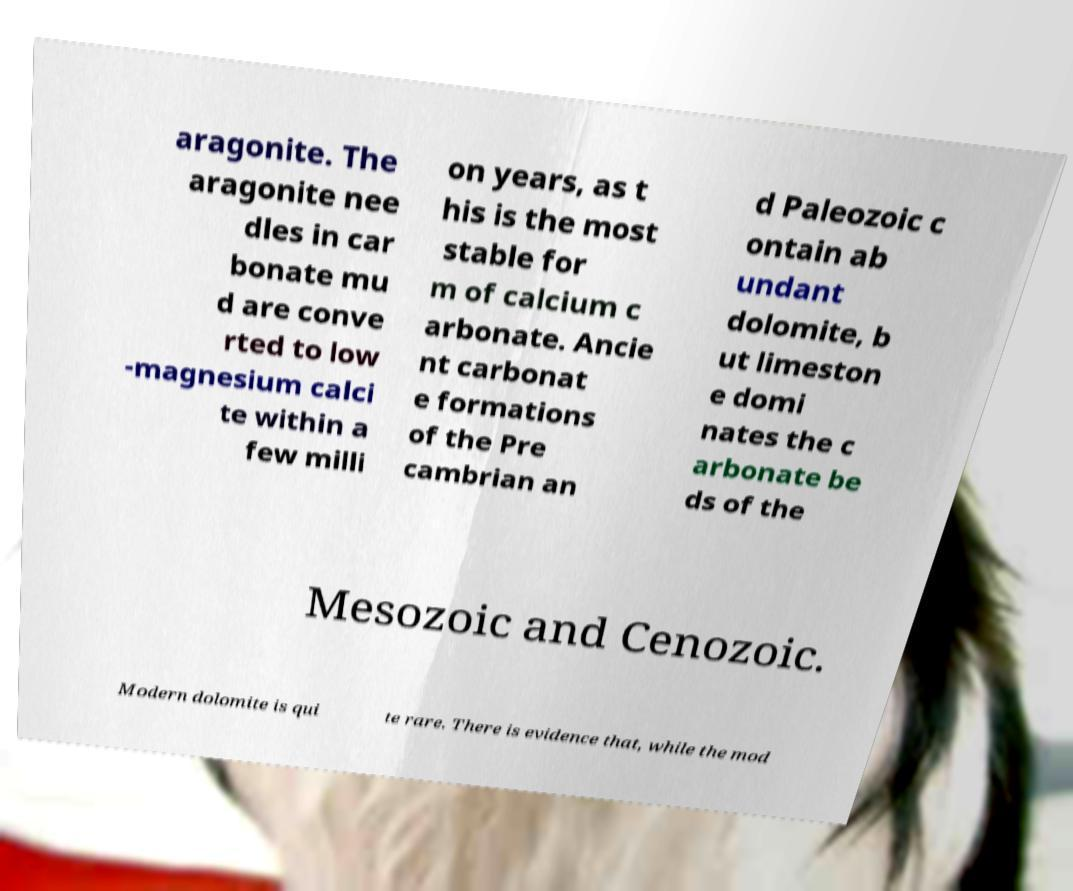Could you extract and type out the text from this image? aragonite. The aragonite nee dles in car bonate mu d are conve rted to low -magnesium calci te within a few milli on years, as t his is the most stable for m of calcium c arbonate. Ancie nt carbonat e formations of the Pre cambrian an d Paleozoic c ontain ab undant dolomite, b ut limeston e domi nates the c arbonate be ds of the Mesozoic and Cenozoic. Modern dolomite is qui te rare. There is evidence that, while the mod 